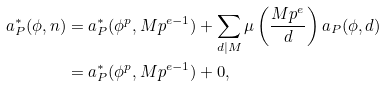<formula> <loc_0><loc_0><loc_500><loc_500>a _ { P } ^ { \ast } ( \phi , n ) & = a _ { P } ^ { \ast } ( \phi ^ { p } , M p ^ { e - 1 } ) + \sum _ { d | M } \mu \left ( \frac { M p ^ { e } } { d } \right ) a _ { P } ( \phi , d ) \\ & = a _ { P } ^ { \ast } ( \phi ^ { p } , M p ^ { e - 1 } ) + 0 ,</formula> 